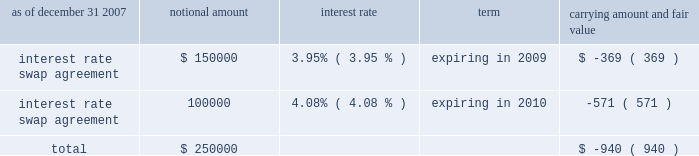American tower corporation and subsidiaries notes to consolidated financial statements 2014 ( continued ) market and lease the unused tower space on the broadcast towers ( the economic rights ) .
Tv azteca retains title to these towers and is responsible for their operation and maintenance .
The company is entitled to 100% ( 100 % ) of the revenues generated from leases with tenants on the unused space and is responsible for any incremental operating expenses associated with those tenants .
The term of the economic rights agreement is seventy years ; however , tv azteca has the right to purchase , at fair market value , the economic rights from the company at any time during the last fifty years of the agreement .
Should tv azteca elect to purchase the economic rights ( in whole or in part ) , it would also be obligated to repay a proportional amount of the loan discussed above at the time of such election .
The company 2019s obligation to pay tv azteca $ 1.5 million annually would also be reduced proportionally .
The company has accounted for the annual payment of $ 1.5 million as a capital lease ( initially recording an asset and a corresponding liability of approximately $ 18.6 million ) .
The capital lease asset and the discount on the note , which aggregate approximately $ 30.2 million , represent the cost to acquire the economic rights and are being amortized over the seventy-year life of the economic rights agreement .
On a quarterly basis , the company assesses the recoverability of its note receivable from tv azteca .
As of december 31 , 2007 and 2006 , the company has assessed the recoverability of the note receivable from tv azteca and concluded that no adjustment to its carrying value is required .
A former executive officer and former director of the company served as a director of tv azteca from december 1999 to february 2006 .
As of december 31 , 2007 and 2006 , the company also had other long-term notes receivable outstanding of approximately $ 4.3 million and $ 11.0 million , respectively .
Derivative financial instruments the company enters into interest rate protection agreements to manage exposure on the variable rate debt under its credit facilities and to manage variability in cash flows relating to forecasted interest payments .
Under these agreements , the company is exposed to credit risk to the extent that a counterparty fails to meet the terms of a contract .
Such exposure was limited to the current value of the contract at the time the counterparty fails to perform .
The company believes its contracts as of december 31 , 2007 and 2006 are with credit worthy institutions .
As of december 31 , 2007 and 2006 , the carrying amounts of the company 2019s derivative financial instruments , along with the estimated fair values of the related assets reflected in notes receivable and other long-term assets and ( liabilities ) reflected in other long-term liabilities in the accompanying consolidated balance sheet , are as follows ( in thousands except percentages ) : as of december 31 , 2007 notional amount interest rate term carrying amount and fair value .

What is the yearly amortization expense for the economic rights agreement assuming an 11 year effective life? 
Computations: ((30.2 / 11) * 1000000)
Answer: 2745454.54545. 